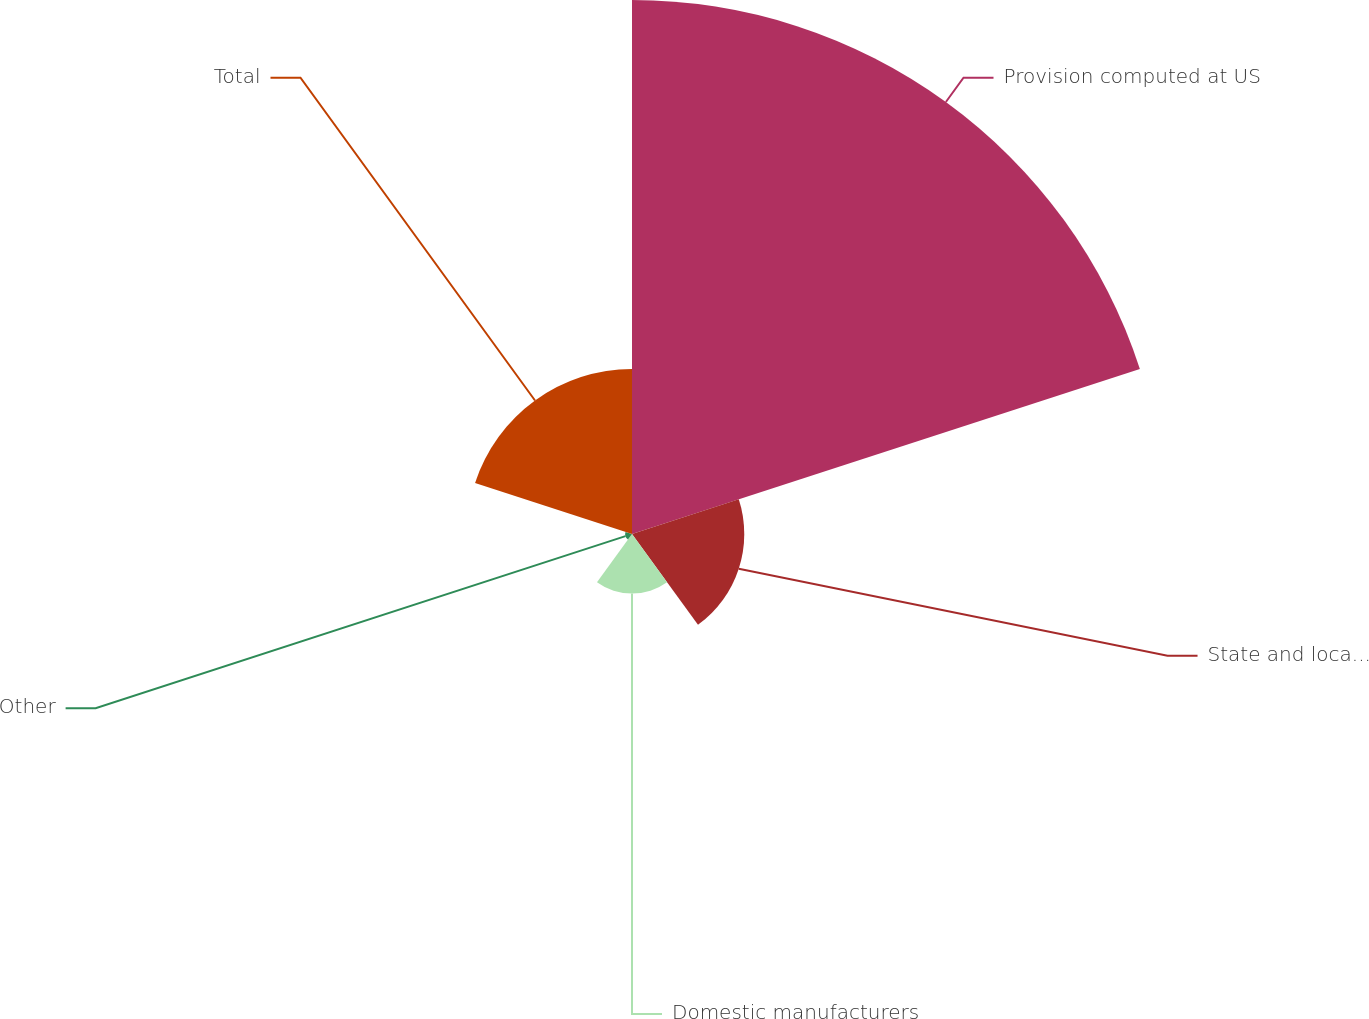<chart> <loc_0><loc_0><loc_500><loc_500><pie_chart><fcel>Provision computed at US<fcel>State and local taxes net of<fcel>Domestic manufacturers<fcel>Other<fcel>Total<nl><fcel>60.84%<fcel>12.79%<fcel>6.79%<fcel>0.78%<fcel>18.8%<nl></chart> 